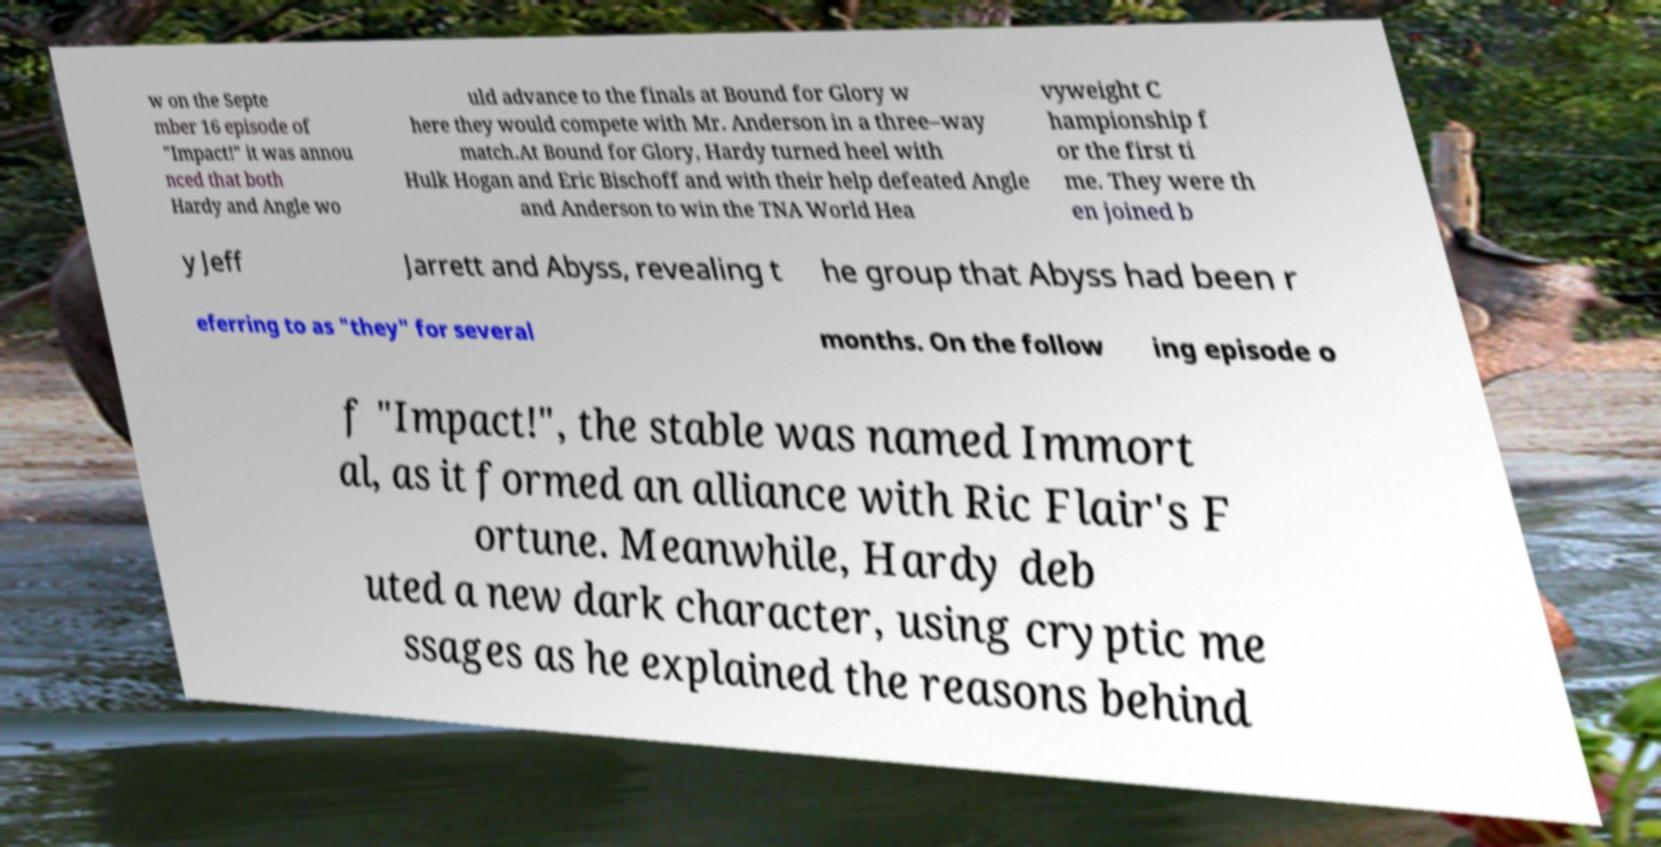I need the written content from this picture converted into text. Can you do that? w on the Septe mber 16 episode of "Impact!" it was annou nced that both Hardy and Angle wo uld advance to the finals at Bound for Glory w here they would compete with Mr. Anderson in a three–way match.At Bound for Glory, Hardy turned heel with Hulk Hogan and Eric Bischoff and with their help defeated Angle and Anderson to win the TNA World Hea vyweight C hampionship f or the first ti me. They were th en joined b y Jeff Jarrett and Abyss, revealing t he group that Abyss had been r eferring to as "they" for several months. On the follow ing episode o f "Impact!", the stable was named Immort al, as it formed an alliance with Ric Flair's F ortune. Meanwhile, Hardy deb uted a new dark character, using cryptic me ssages as he explained the reasons behind 